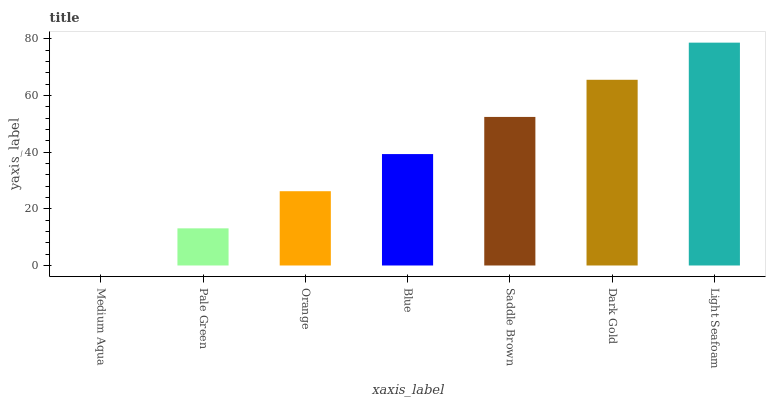Is Pale Green the minimum?
Answer yes or no. No. Is Pale Green the maximum?
Answer yes or no. No. Is Pale Green greater than Medium Aqua?
Answer yes or no. Yes. Is Medium Aqua less than Pale Green?
Answer yes or no. Yes. Is Medium Aqua greater than Pale Green?
Answer yes or no. No. Is Pale Green less than Medium Aqua?
Answer yes or no. No. Is Blue the high median?
Answer yes or no. Yes. Is Blue the low median?
Answer yes or no. Yes. Is Light Seafoam the high median?
Answer yes or no. No. Is Saddle Brown the low median?
Answer yes or no. No. 